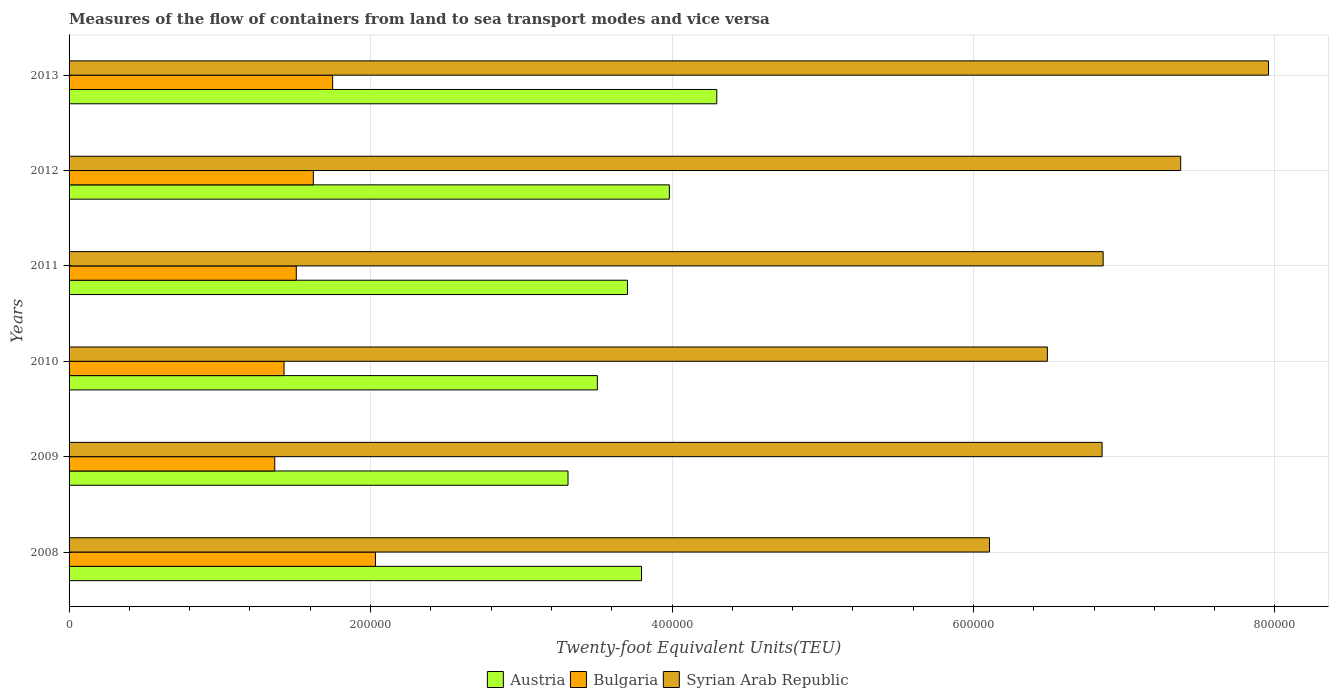Are the number of bars per tick equal to the number of legend labels?
Your response must be concise. Yes. How many bars are there on the 2nd tick from the top?
Provide a succinct answer. 3. In how many cases, is the number of bars for a given year not equal to the number of legend labels?
Your response must be concise. 0. What is the container port traffic in Bulgaria in 2008?
Provide a succinct answer. 2.03e+05. Across all years, what is the maximum container port traffic in Austria?
Offer a very short reply. 4.30e+05. Across all years, what is the minimum container port traffic in Syrian Arab Republic?
Your answer should be compact. 6.11e+05. What is the total container port traffic in Syrian Arab Republic in the graph?
Your answer should be very brief. 4.16e+06. What is the difference between the container port traffic in Austria in 2009 and that in 2010?
Provide a short and direct response. -1.95e+04. What is the difference between the container port traffic in Austria in 2009 and the container port traffic in Syrian Arab Republic in 2013?
Keep it short and to the point. -4.65e+05. What is the average container port traffic in Syrian Arab Republic per year?
Provide a succinct answer. 6.94e+05. In the year 2008, what is the difference between the container port traffic in Bulgaria and container port traffic in Austria?
Keep it short and to the point. -1.76e+05. In how many years, is the container port traffic in Austria greater than 520000 TEU?
Provide a short and direct response. 0. What is the ratio of the container port traffic in Austria in 2010 to that in 2011?
Your answer should be compact. 0.95. Is the difference between the container port traffic in Bulgaria in 2009 and 2013 greater than the difference between the container port traffic in Austria in 2009 and 2013?
Make the answer very short. Yes. What is the difference between the highest and the second highest container port traffic in Bulgaria?
Your response must be concise. 2.84e+04. What is the difference between the highest and the lowest container port traffic in Austria?
Your response must be concise. 9.87e+04. Is the sum of the container port traffic in Bulgaria in 2011 and 2013 greater than the maximum container port traffic in Austria across all years?
Offer a very short reply. No. What does the 3rd bar from the top in 2010 represents?
Your answer should be compact. Austria. What does the 3rd bar from the bottom in 2012 represents?
Provide a short and direct response. Syrian Arab Republic. Is it the case that in every year, the sum of the container port traffic in Syrian Arab Republic and container port traffic in Bulgaria is greater than the container port traffic in Austria?
Your response must be concise. Yes. How many bars are there?
Provide a short and direct response. 18. Are all the bars in the graph horizontal?
Offer a terse response. Yes. How many years are there in the graph?
Give a very brief answer. 6. What is the difference between two consecutive major ticks on the X-axis?
Ensure brevity in your answer.  2.00e+05. Does the graph contain any zero values?
Your answer should be compact. No. Does the graph contain grids?
Offer a very short reply. Yes. Where does the legend appear in the graph?
Provide a short and direct response. Bottom center. What is the title of the graph?
Offer a terse response. Measures of the flow of containers from land to sea transport modes and vice versa. Does "Sweden" appear as one of the legend labels in the graph?
Offer a terse response. No. What is the label or title of the X-axis?
Make the answer very short. Twenty-foot Equivalent Units(TEU). What is the Twenty-foot Equivalent Units(TEU) in Austria in 2008?
Make the answer very short. 3.80e+05. What is the Twenty-foot Equivalent Units(TEU) of Bulgaria in 2008?
Provide a succinct answer. 2.03e+05. What is the Twenty-foot Equivalent Units(TEU) of Syrian Arab Republic in 2008?
Offer a very short reply. 6.11e+05. What is the Twenty-foot Equivalent Units(TEU) in Austria in 2009?
Ensure brevity in your answer.  3.31e+05. What is the Twenty-foot Equivalent Units(TEU) in Bulgaria in 2009?
Make the answer very short. 1.36e+05. What is the Twenty-foot Equivalent Units(TEU) of Syrian Arab Republic in 2009?
Keep it short and to the point. 6.85e+05. What is the Twenty-foot Equivalent Units(TEU) of Austria in 2010?
Keep it short and to the point. 3.50e+05. What is the Twenty-foot Equivalent Units(TEU) of Bulgaria in 2010?
Ensure brevity in your answer.  1.43e+05. What is the Twenty-foot Equivalent Units(TEU) of Syrian Arab Republic in 2010?
Provide a succinct answer. 6.49e+05. What is the Twenty-foot Equivalent Units(TEU) in Austria in 2011?
Ensure brevity in your answer.  3.70e+05. What is the Twenty-foot Equivalent Units(TEU) of Bulgaria in 2011?
Keep it short and to the point. 1.51e+05. What is the Twenty-foot Equivalent Units(TEU) of Syrian Arab Republic in 2011?
Give a very brief answer. 6.86e+05. What is the Twenty-foot Equivalent Units(TEU) in Austria in 2012?
Provide a short and direct response. 3.98e+05. What is the Twenty-foot Equivalent Units(TEU) of Bulgaria in 2012?
Offer a very short reply. 1.62e+05. What is the Twenty-foot Equivalent Units(TEU) in Syrian Arab Republic in 2012?
Make the answer very short. 7.37e+05. What is the Twenty-foot Equivalent Units(TEU) of Austria in 2013?
Offer a very short reply. 4.30e+05. What is the Twenty-foot Equivalent Units(TEU) of Bulgaria in 2013?
Offer a terse response. 1.75e+05. What is the Twenty-foot Equivalent Units(TEU) in Syrian Arab Republic in 2013?
Provide a succinct answer. 7.96e+05. Across all years, what is the maximum Twenty-foot Equivalent Units(TEU) in Austria?
Provide a succinct answer. 4.30e+05. Across all years, what is the maximum Twenty-foot Equivalent Units(TEU) in Bulgaria?
Your response must be concise. 2.03e+05. Across all years, what is the maximum Twenty-foot Equivalent Units(TEU) in Syrian Arab Republic?
Provide a succinct answer. 7.96e+05. Across all years, what is the minimum Twenty-foot Equivalent Units(TEU) in Austria?
Offer a very short reply. 3.31e+05. Across all years, what is the minimum Twenty-foot Equivalent Units(TEU) of Bulgaria?
Your answer should be very brief. 1.36e+05. Across all years, what is the minimum Twenty-foot Equivalent Units(TEU) in Syrian Arab Republic?
Your response must be concise. 6.11e+05. What is the total Twenty-foot Equivalent Units(TEU) in Austria in the graph?
Offer a very short reply. 2.26e+06. What is the total Twenty-foot Equivalent Units(TEU) of Bulgaria in the graph?
Make the answer very short. 9.70e+05. What is the total Twenty-foot Equivalent Units(TEU) of Syrian Arab Republic in the graph?
Give a very brief answer. 4.16e+06. What is the difference between the Twenty-foot Equivalent Units(TEU) in Austria in 2008 and that in 2009?
Offer a very short reply. 4.87e+04. What is the difference between the Twenty-foot Equivalent Units(TEU) in Bulgaria in 2008 and that in 2009?
Offer a terse response. 6.68e+04. What is the difference between the Twenty-foot Equivalent Units(TEU) of Syrian Arab Republic in 2008 and that in 2009?
Offer a very short reply. -7.47e+04. What is the difference between the Twenty-foot Equivalent Units(TEU) in Austria in 2008 and that in 2010?
Provide a succinct answer. 2.93e+04. What is the difference between the Twenty-foot Equivalent Units(TEU) in Bulgaria in 2008 and that in 2010?
Offer a very short reply. 6.06e+04. What is the difference between the Twenty-foot Equivalent Units(TEU) in Syrian Arab Republic in 2008 and that in 2010?
Make the answer very short. -3.84e+04. What is the difference between the Twenty-foot Equivalent Units(TEU) of Austria in 2008 and that in 2011?
Offer a terse response. 9303.43. What is the difference between the Twenty-foot Equivalent Units(TEU) of Bulgaria in 2008 and that in 2011?
Your answer should be very brief. 5.25e+04. What is the difference between the Twenty-foot Equivalent Units(TEU) of Syrian Arab Republic in 2008 and that in 2011?
Offer a very short reply. -7.54e+04. What is the difference between the Twenty-foot Equivalent Units(TEU) of Austria in 2008 and that in 2012?
Your answer should be compact. -1.85e+04. What is the difference between the Twenty-foot Equivalent Units(TEU) of Bulgaria in 2008 and that in 2012?
Offer a very short reply. 4.12e+04. What is the difference between the Twenty-foot Equivalent Units(TEU) of Syrian Arab Republic in 2008 and that in 2012?
Give a very brief answer. -1.27e+05. What is the difference between the Twenty-foot Equivalent Units(TEU) of Austria in 2008 and that in 2013?
Offer a very short reply. -4.99e+04. What is the difference between the Twenty-foot Equivalent Units(TEU) in Bulgaria in 2008 and that in 2013?
Offer a terse response. 2.84e+04. What is the difference between the Twenty-foot Equivalent Units(TEU) of Syrian Arab Republic in 2008 and that in 2013?
Your answer should be compact. -1.85e+05. What is the difference between the Twenty-foot Equivalent Units(TEU) in Austria in 2009 and that in 2010?
Keep it short and to the point. -1.95e+04. What is the difference between the Twenty-foot Equivalent Units(TEU) in Bulgaria in 2009 and that in 2010?
Your answer should be very brief. -6167. What is the difference between the Twenty-foot Equivalent Units(TEU) in Syrian Arab Republic in 2009 and that in 2010?
Offer a very short reply. 3.63e+04. What is the difference between the Twenty-foot Equivalent Units(TEU) in Austria in 2009 and that in 2011?
Offer a terse response. -3.94e+04. What is the difference between the Twenty-foot Equivalent Units(TEU) in Bulgaria in 2009 and that in 2011?
Keep it short and to the point. -1.43e+04. What is the difference between the Twenty-foot Equivalent Units(TEU) in Syrian Arab Republic in 2009 and that in 2011?
Ensure brevity in your answer.  -699.28. What is the difference between the Twenty-foot Equivalent Units(TEU) in Austria in 2009 and that in 2012?
Keep it short and to the point. -6.72e+04. What is the difference between the Twenty-foot Equivalent Units(TEU) of Bulgaria in 2009 and that in 2012?
Offer a very short reply. -2.56e+04. What is the difference between the Twenty-foot Equivalent Units(TEU) in Syrian Arab Republic in 2009 and that in 2012?
Your answer should be compact. -5.21e+04. What is the difference between the Twenty-foot Equivalent Units(TEU) of Austria in 2009 and that in 2013?
Your answer should be compact. -9.87e+04. What is the difference between the Twenty-foot Equivalent Units(TEU) in Bulgaria in 2009 and that in 2013?
Your response must be concise. -3.84e+04. What is the difference between the Twenty-foot Equivalent Units(TEU) of Syrian Arab Republic in 2009 and that in 2013?
Keep it short and to the point. -1.10e+05. What is the difference between the Twenty-foot Equivalent Units(TEU) in Austria in 2010 and that in 2011?
Offer a terse response. -2.00e+04. What is the difference between the Twenty-foot Equivalent Units(TEU) in Bulgaria in 2010 and that in 2011?
Your response must be concise. -8128.83. What is the difference between the Twenty-foot Equivalent Units(TEU) in Syrian Arab Republic in 2010 and that in 2011?
Your answer should be compact. -3.70e+04. What is the difference between the Twenty-foot Equivalent Units(TEU) in Austria in 2010 and that in 2012?
Give a very brief answer. -4.78e+04. What is the difference between the Twenty-foot Equivalent Units(TEU) of Bulgaria in 2010 and that in 2012?
Offer a very short reply. -1.94e+04. What is the difference between the Twenty-foot Equivalent Units(TEU) in Syrian Arab Republic in 2010 and that in 2012?
Your answer should be very brief. -8.84e+04. What is the difference between the Twenty-foot Equivalent Units(TEU) in Austria in 2010 and that in 2013?
Your answer should be very brief. -7.92e+04. What is the difference between the Twenty-foot Equivalent Units(TEU) of Bulgaria in 2010 and that in 2013?
Your answer should be compact. -3.22e+04. What is the difference between the Twenty-foot Equivalent Units(TEU) in Syrian Arab Republic in 2010 and that in 2013?
Provide a short and direct response. -1.47e+05. What is the difference between the Twenty-foot Equivalent Units(TEU) of Austria in 2011 and that in 2012?
Provide a succinct answer. -2.78e+04. What is the difference between the Twenty-foot Equivalent Units(TEU) of Bulgaria in 2011 and that in 2012?
Ensure brevity in your answer.  -1.13e+04. What is the difference between the Twenty-foot Equivalent Units(TEU) of Syrian Arab Republic in 2011 and that in 2012?
Ensure brevity in your answer.  -5.14e+04. What is the difference between the Twenty-foot Equivalent Units(TEU) in Austria in 2011 and that in 2013?
Your answer should be very brief. -5.92e+04. What is the difference between the Twenty-foot Equivalent Units(TEU) of Bulgaria in 2011 and that in 2013?
Ensure brevity in your answer.  -2.41e+04. What is the difference between the Twenty-foot Equivalent Units(TEU) in Syrian Arab Republic in 2011 and that in 2013?
Keep it short and to the point. -1.10e+05. What is the difference between the Twenty-foot Equivalent Units(TEU) in Austria in 2012 and that in 2013?
Offer a terse response. -3.15e+04. What is the difference between the Twenty-foot Equivalent Units(TEU) of Bulgaria in 2012 and that in 2013?
Provide a short and direct response. -1.28e+04. What is the difference between the Twenty-foot Equivalent Units(TEU) in Syrian Arab Republic in 2012 and that in 2013?
Your answer should be compact. -5.83e+04. What is the difference between the Twenty-foot Equivalent Units(TEU) in Austria in 2008 and the Twenty-foot Equivalent Units(TEU) in Bulgaria in 2009?
Offer a terse response. 2.43e+05. What is the difference between the Twenty-foot Equivalent Units(TEU) in Austria in 2008 and the Twenty-foot Equivalent Units(TEU) in Syrian Arab Republic in 2009?
Provide a succinct answer. -3.06e+05. What is the difference between the Twenty-foot Equivalent Units(TEU) in Bulgaria in 2008 and the Twenty-foot Equivalent Units(TEU) in Syrian Arab Republic in 2009?
Provide a short and direct response. -4.82e+05. What is the difference between the Twenty-foot Equivalent Units(TEU) in Austria in 2008 and the Twenty-foot Equivalent Units(TEU) in Bulgaria in 2010?
Offer a very short reply. 2.37e+05. What is the difference between the Twenty-foot Equivalent Units(TEU) of Austria in 2008 and the Twenty-foot Equivalent Units(TEU) of Syrian Arab Republic in 2010?
Offer a terse response. -2.69e+05. What is the difference between the Twenty-foot Equivalent Units(TEU) in Bulgaria in 2008 and the Twenty-foot Equivalent Units(TEU) in Syrian Arab Republic in 2010?
Provide a short and direct response. -4.46e+05. What is the difference between the Twenty-foot Equivalent Units(TEU) in Austria in 2008 and the Twenty-foot Equivalent Units(TEU) in Bulgaria in 2011?
Your response must be concise. 2.29e+05. What is the difference between the Twenty-foot Equivalent Units(TEU) in Austria in 2008 and the Twenty-foot Equivalent Units(TEU) in Syrian Arab Republic in 2011?
Provide a succinct answer. -3.06e+05. What is the difference between the Twenty-foot Equivalent Units(TEU) of Bulgaria in 2008 and the Twenty-foot Equivalent Units(TEU) of Syrian Arab Republic in 2011?
Ensure brevity in your answer.  -4.83e+05. What is the difference between the Twenty-foot Equivalent Units(TEU) in Austria in 2008 and the Twenty-foot Equivalent Units(TEU) in Bulgaria in 2012?
Keep it short and to the point. 2.18e+05. What is the difference between the Twenty-foot Equivalent Units(TEU) of Austria in 2008 and the Twenty-foot Equivalent Units(TEU) of Syrian Arab Republic in 2012?
Provide a short and direct response. -3.58e+05. What is the difference between the Twenty-foot Equivalent Units(TEU) of Bulgaria in 2008 and the Twenty-foot Equivalent Units(TEU) of Syrian Arab Republic in 2012?
Provide a short and direct response. -5.34e+05. What is the difference between the Twenty-foot Equivalent Units(TEU) of Austria in 2008 and the Twenty-foot Equivalent Units(TEU) of Bulgaria in 2013?
Your response must be concise. 2.05e+05. What is the difference between the Twenty-foot Equivalent Units(TEU) of Austria in 2008 and the Twenty-foot Equivalent Units(TEU) of Syrian Arab Republic in 2013?
Offer a terse response. -4.16e+05. What is the difference between the Twenty-foot Equivalent Units(TEU) of Bulgaria in 2008 and the Twenty-foot Equivalent Units(TEU) of Syrian Arab Republic in 2013?
Your response must be concise. -5.92e+05. What is the difference between the Twenty-foot Equivalent Units(TEU) of Austria in 2009 and the Twenty-foot Equivalent Units(TEU) of Bulgaria in 2010?
Offer a very short reply. 1.88e+05. What is the difference between the Twenty-foot Equivalent Units(TEU) in Austria in 2009 and the Twenty-foot Equivalent Units(TEU) in Syrian Arab Republic in 2010?
Your answer should be compact. -3.18e+05. What is the difference between the Twenty-foot Equivalent Units(TEU) in Bulgaria in 2009 and the Twenty-foot Equivalent Units(TEU) in Syrian Arab Republic in 2010?
Offer a terse response. -5.13e+05. What is the difference between the Twenty-foot Equivalent Units(TEU) in Austria in 2009 and the Twenty-foot Equivalent Units(TEU) in Bulgaria in 2011?
Your answer should be very brief. 1.80e+05. What is the difference between the Twenty-foot Equivalent Units(TEU) in Austria in 2009 and the Twenty-foot Equivalent Units(TEU) in Syrian Arab Republic in 2011?
Provide a succinct answer. -3.55e+05. What is the difference between the Twenty-foot Equivalent Units(TEU) in Bulgaria in 2009 and the Twenty-foot Equivalent Units(TEU) in Syrian Arab Republic in 2011?
Your answer should be compact. -5.50e+05. What is the difference between the Twenty-foot Equivalent Units(TEU) in Austria in 2009 and the Twenty-foot Equivalent Units(TEU) in Bulgaria in 2012?
Your answer should be very brief. 1.69e+05. What is the difference between the Twenty-foot Equivalent Units(TEU) in Austria in 2009 and the Twenty-foot Equivalent Units(TEU) in Syrian Arab Republic in 2012?
Provide a short and direct response. -4.06e+05. What is the difference between the Twenty-foot Equivalent Units(TEU) of Bulgaria in 2009 and the Twenty-foot Equivalent Units(TEU) of Syrian Arab Republic in 2012?
Offer a terse response. -6.01e+05. What is the difference between the Twenty-foot Equivalent Units(TEU) of Austria in 2009 and the Twenty-foot Equivalent Units(TEU) of Bulgaria in 2013?
Your answer should be very brief. 1.56e+05. What is the difference between the Twenty-foot Equivalent Units(TEU) of Austria in 2009 and the Twenty-foot Equivalent Units(TEU) of Syrian Arab Republic in 2013?
Your answer should be compact. -4.65e+05. What is the difference between the Twenty-foot Equivalent Units(TEU) of Bulgaria in 2009 and the Twenty-foot Equivalent Units(TEU) of Syrian Arab Republic in 2013?
Provide a succinct answer. -6.59e+05. What is the difference between the Twenty-foot Equivalent Units(TEU) of Austria in 2010 and the Twenty-foot Equivalent Units(TEU) of Bulgaria in 2011?
Make the answer very short. 2.00e+05. What is the difference between the Twenty-foot Equivalent Units(TEU) in Austria in 2010 and the Twenty-foot Equivalent Units(TEU) in Syrian Arab Republic in 2011?
Your response must be concise. -3.36e+05. What is the difference between the Twenty-foot Equivalent Units(TEU) in Bulgaria in 2010 and the Twenty-foot Equivalent Units(TEU) in Syrian Arab Republic in 2011?
Offer a terse response. -5.43e+05. What is the difference between the Twenty-foot Equivalent Units(TEU) of Austria in 2010 and the Twenty-foot Equivalent Units(TEU) of Bulgaria in 2012?
Give a very brief answer. 1.88e+05. What is the difference between the Twenty-foot Equivalent Units(TEU) in Austria in 2010 and the Twenty-foot Equivalent Units(TEU) in Syrian Arab Republic in 2012?
Give a very brief answer. -3.87e+05. What is the difference between the Twenty-foot Equivalent Units(TEU) of Bulgaria in 2010 and the Twenty-foot Equivalent Units(TEU) of Syrian Arab Republic in 2012?
Offer a terse response. -5.95e+05. What is the difference between the Twenty-foot Equivalent Units(TEU) in Austria in 2010 and the Twenty-foot Equivalent Units(TEU) in Bulgaria in 2013?
Keep it short and to the point. 1.76e+05. What is the difference between the Twenty-foot Equivalent Units(TEU) in Austria in 2010 and the Twenty-foot Equivalent Units(TEU) in Syrian Arab Republic in 2013?
Make the answer very short. -4.45e+05. What is the difference between the Twenty-foot Equivalent Units(TEU) in Bulgaria in 2010 and the Twenty-foot Equivalent Units(TEU) in Syrian Arab Republic in 2013?
Your answer should be compact. -6.53e+05. What is the difference between the Twenty-foot Equivalent Units(TEU) in Austria in 2011 and the Twenty-foot Equivalent Units(TEU) in Bulgaria in 2012?
Give a very brief answer. 2.08e+05. What is the difference between the Twenty-foot Equivalent Units(TEU) of Austria in 2011 and the Twenty-foot Equivalent Units(TEU) of Syrian Arab Republic in 2012?
Keep it short and to the point. -3.67e+05. What is the difference between the Twenty-foot Equivalent Units(TEU) of Bulgaria in 2011 and the Twenty-foot Equivalent Units(TEU) of Syrian Arab Republic in 2012?
Make the answer very short. -5.87e+05. What is the difference between the Twenty-foot Equivalent Units(TEU) in Austria in 2011 and the Twenty-foot Equivalent Units(TEU) in Bulgaria in 2013?
Offer a terse response. 1.96e+05. What is the difference between the Twenty-foot Equivalent Units(TEU) of Austria in 2011 and the Twenty-foot Equivalent Units(TEU) of Syrian Arab Republic in 2013?
Provide a succinct answer. -4.25e+05. What is the difference between the Twenty-foot Equivalent Units(TEU) of Bulgaria in 2011 and the Twenty-foot Equivalent Units(TEU) of Syrian Arab Republic in 2013?
Provide a succinct answer. -6.45e+05. What is the difference between the Twenty-foot Equivalent Units(TEU) of Austria in 2012 and the Twenty-foot Equivalent Units(TEU) of Bulgaria in 2013?
Ensure brevity in your answer.  2.23e+05. What is the difference between the Twenty-foot Equivalent Units(TEU) in Austria in 2012 and the Twenty-foot Equivalent Units(TEU) in Syrian Arab Republic in 2013?
Give a very brief answer. -3.97e+05. What is the difference between the Twenty-foot Equivalent Units(TEU) in Bulgaria in 2012 and the Twenty-foot Equivalent Units(TEU) in Syrian Arab Republic in 2013?
Your response must be concise. -6.34e+05. What is the average Twenty-foot Equivalent Units(TEU) in Austria per year?
Make the answer very short. 3.77e+05. What is the average Twenty-foot Equivalent Units(TEU) of Bulgaria per year?
Your response must be concise. 1.62e+05. What is the average Twenty-foot Equivalent Units(TEU) of Syrian Arab Republic per year?
Provide a succinct answer. 6.94e+05. In the year 2008, what is the difference between the Twenty-foot Equivalent Units(TEU) of Austria and Twenty-foot Equivalent Units(TEU) of Bulgaria?
Provide a short and direct response. 1.76e+05. In the year 2008, what is the difference between the Twenty-foot Equivalent Units(TEU) of Austria and Twenty-foot Equivalent Units(TEU) of Syrian Arab Republic?
Give a very brief answer. -2.31e+05. In the year 2008, what is the difference between the Twenty-foot Equivalent Units(TEU) in Bulgaria and Twenty-foot Equivalent Units(TEU) in Syrian Arab Republic?
Offer a very short reply. -4.07e+05. In the year 2009, what is the difference between the Twenty-foot Equivalent Units(TEU) of Austria and Twenty-foot Equivalent Units(TEU) of Bulgaria?
Provide a short and direct response. 1.95e+05. In the year 2009, what is the difference between the Twenty-foot Equivalent Units(TEU) of Austria and Twenty-foot Equivalent Units(TEU) of Syrian Arab Republic?
Offer a terse response. -3.54e+05. In the year 2009, what is the difference between the Twenty-foot Equivalent Units(TEU) of Bulgaria and Twenty-foot Equivalent Units(TEU) of Syrian Arab Republic?
Ensure brevity in your answer.  -5.49e+05. In the year 2010, what is the difference between the Twenty-foot Equivalent Units(TEU) in Austria and Twenty-foot Equivalent Units(TEU) in Bulgaria?
Offer a very short reply. 2.08e+05. In the year 2010, what is the difference between the Twenty-foot Equivalent Units(TEU) in Austria and Twenty-foot Equivalent Units(TEU) in Syrian Arab Republic?
Your response must be concise. -2.99e+05. In the year 2010, what is the difference between the Twenty-foot Equivalent Units(TEU) in Bulgaria and Twenty-foot Equivalent Units(TEU) in Syrian Arab Republic?
Your response must be concise. -5.06e+05. In the year 2011, what is the difference between the Twenty-foot Equivalent Units(TEU) of Austria and Twenty-foot Equivalent Units(TEU) of Bulgaria?
Provide a short and direct response. 2.20e+05. In the year 2011, what is the difference between the Twenty-foot Equivalent Units(TEU) in Austria and Twenty-foot Equivalent Units(TEU) in Syrian Arab Republic?
Keep it short and to the point. -3.16e+05. In the year 2011, what is the difference between the Twenty-foot Equivalent Units(TEU) of Bulgaria and Twenty-foot Equivalent Units(TEU) of Syrian Arab Republic?
Your response must be concise. -5.35e+05. In the year 2012, what is the difference between the Twenty-foot Equivalent Units(TEU) in Austria and Twenty-foot Equivalent Units(TEU) in Bulgaria?
Give a very brief answer. 2.36e+05. In the year 2012, what is the difference between the Twenty-foot Equivalent Units(TEU) of Austria and Twenty-foot Equivalent Units(TEU) of Syrian Arab Republic?
Offer a terse response. -3.39e+05. In the year 2012, what is the difference between the Twenty-foot Equivalent Units(TEU) in Bulgaria and Twenty-foot Equivalent Units(TEU) in Syrian Arab Republic?
Give a very brief answer. -5.75e+05. In the year 2013, what is the difference between the Twenty-foot Equivalent Units(TEU) in Austria and Twenty-foot Equivalent Units(TEU) in Bulgaria?
Your answer should be compact. 2.55e+05. In the year 2013, what is the difference between the Twenty-foot Equivalent Units(TEU) of Austria and Twenty-foot Equivalent Units(TEU) of Syrian Arab Republic?
Ensure brevity in your answer.  -3.66e+05. In the year 2013, what is the difference between the Twenty-foot Equivalent Units(TEU) in Bulgaria and Twenty-foot Equivalent Units(TEU) in Syrian Arab Republic?
Give a very brief answer. -6.21e+05. What is the ratio of the Twenty-foot Equivalent Units(TEU) of Austria in 2008 to that in 2009?
Offer a terse response. 1.15. What is the ratio of the Twenty-foot Equivalent Units(TEU) in Bulgaria in 2008 to that in 2009?
Provide a succinct answer. 1.49. What is the ratio of the Twenty-foot Equivalent Units(TEU) in Syrian Arab Republic in 2008 to that in 2009?
Provide a short and direct response. 0.89. What is the ratio of the Twenty-foot Equivalent Units(TEU) of Austria in 2008 to that in 2010?
Provide a short and direct response. 1.08. What is the ratio of the Twenty-foot Equivalent Units(TEU) of Bulgaria in 2008 to that in 2010?
Provide a short and direct response. 1.43. What is the ratio of the Twenty-foot Equivalent Units(TEU) in Syrian Arab Republic in 2008 to that in 2010?
Keep it short and to the point. 0.94. What is the ratio of the Twenty-foot Equivalent Units(TEU) in Austria in 2008 to that in 2011?
Offer a terse response. 1.03. What is the ratio of the Twenty-foot Equivalent Units(TEU) of Bulgaria in 2008 to that in 2011?
Keep it short and to the point. 1.35. What is the ratio of the Twenty-foot Equivalent Units(TEU) of Syrian Arab Republic in 2008 to that in 2011?
Keep it short and to the point. 0.89. What is the ratio of the Twenty-foot Equivalent Units(TEU) in Austria in 2008 to that in 2012?
Offer a very short reply. 0.95. What is the ratio of the Twenty-foot Equivalent Units(TEU) in Bulgaria in 2008 to that in 2012?
Give a very brief answer. 1.25. What is the ratio of the Twenty-foot Equivalent Units(TEU) in Syrian Arab Republic in 2008 to that in 2012?
Ensure brevity in your answer.  0.83. What is the ratio of the Twenty-foot Equivalent Units(TEU) in Austria in 2008 to that in 2013?
Ensure brevity in your answer.  0.88. What is the ratio of the Twenty-foot Equivalent Units(TEU) of Bulgaria in 2008 to that in 2013?
Your answer should be compact. 1.16. What is the ratio of the Twenty-foot Equivalent Units(TEU) in Syrian Arab Republic in 2008 to that in 2013?
Ensure brevity in your answer.  0.77. What is the ratio of the Twenty-foot Equivalent Units(TEU) in Austria in 2009 to that in 2010?
Your response must be concise. 0.94. What is the ratio of the Twenty-foot Equivalent Units(TEU) in Bulgaria in 2009 to that in 2010?
Provide a succinct answer. 0.96. What is the ratio of the Twenty-foot Equivalent Units(TEU) in Syrian Arab Republic in 2009 to that in 2010?
Make the answer very short. 1.06. What is the ratio of the Twenty-foot Equivalent Units(TEU) in Austria in 2009 to that in 2011?
Your response must be concise. 0.89. What is the ratio of the Twenty-foot Equivalent Units(TEU) of Bulgaria in 2009 to that in 2011?
Your answer should be very brief. 0.91. What is the ratio of the Twenty-foot Equivalent Units(TEU) in Austria in 2009 to that in 2012?
Give a very brief answer. 0.83. What is the ratio of the Twenty-foot Equivalent Units(TEU) in Bulgaria in 2009 to that in 2012?
Offer a terse response. 0.84. What is the ratio of the Twenty-foot Equivalent Units(TEU) of Syrian Arab Republic in 2009 to that in 2012?
Your answer should be compact. 0.93. What is the ratio of the Twenty-foot Equivalent Units(TEU) in Austria in 2009 to that in 2013?
Offer a very short reply. 0.77. What is the ratio of the Twenty-foot Equivalent Units(TEU) in Bulgaria in 2009 to that in 2013?
Ensure brevity in your answer.  0.78. What is the ratio of the Twenty-foot Equivalent Units(TEU) of Syrian Arab Republic in 2009 to that in 2013?
Your answer should be compact. 0.86. What is the ratio of the Twenty-foot Equivalent Units(TEU) in Austria in 2010 to that in 2011?
Offer a very short reply. 0.95. What is the ratio of the Twenty-foot Equivalent Units(TEU) of Bulgaria in 2010 to that in 2011?
Your response must be concise. 0.95. What is the ratio of the Twenty-foot Equivalent Units(TEU) of Syrian Arab Republic in 2010 to that in 2011?
Make the answer very short. 0.95. What is the ratio of the Twenty-foot Equivalent Units(TEU) in Austria in 2010 to that in 2012?
Ensure brevity in your answer.  0.88. What is the ratio of the Twenty-foot Equivalent Units(TEU) of Bulgaria in 2010 to that in 2012?
Keep it short and to the point. 0.88. What is the ratio of the Twenty-foot Equivalent Units(TEU) of Syrian Arab Republic in 2010 to that in 2012?
Your answer should be very brief. 0.88. What is the ratio of the Twenty-foot Equivalent Units(TEU) of Austria in 2010 to that in 2013?
Your response must be concise. 0.82. What is the ratio of the Twenty-foot Equivalent Units(TEU) in Bulgaria in 2010 to that in 2013?
Offer a terse response. 0.82. What is the ratio of the Twenty-foot Equivalent Units(TEU) of Syrian Arab Republic in 2010 to that in 2013?
Make the answer very short. 0.82. What is the ratio of the Twenty-foot Equivalent Units(TEU) in Austria in 2011 to that in 2012?
Give a very brief answer. 0.93. What is the ratio of the Twenty-foot Equivalent Units(TEU) in Bulgaria in 2011 to that in 2012?
Make the answer very short. 0.93. What is the ratio of the Twenty-foot Equivalent Units(TEU) in Syrian Arab Republic in 2011 to that in 2012?
Your response must be concise. 0.93. What is the ratio of the Twenty-foot Equivalent Units(TEU) in Austria in 2011 to that in 2013?
Your response must be concise. 0.86. What is the ratio of the Twenty-foot Equivalent Units(TEU) in Bulgaria in 2011 to that in 2013?
Offer a terse response. 0.86. What is the ratio of the Twenty-foot Equivalent Units(TEU) of Syrian Arab Republic in 2011 to that in 2013?
Offer a terse response. 0.86. What is the ratio of the Twenty-foot Equivalent Units(TEU) of Austria in 2012 to that in 2013?
Give a very brief answer. 0.93. What is the ratio of the Twenty-foot Equivalent Units(TEU) in Bulgaria in 2012 to that in 2013?
Provide a succinct answer. 0.93. What is the ratio of the Twenty-foot Equivalent Units(TEU) of Syrian Arab Republic in 2012 to that in 2013?
Your answer should be compact. 0.93. What is the difference between the highest and the second highest Twenty-foot Equivalent Units(TEU) of Austria?
Your answer should be very brief. 3.15e+04. What is the difference between the highest and the second highest Twenty-foot Equivalent Units(TEU) of Bulgaria?
Your answer should be very brief. 2.84e+04. What is the difference between the highest and the second highest Twenty-foot Equivalent Units(TEU) of Syrian Arab Republic?
Make the answer very short. 5.83e+04. What is the difference between the highest and the lowest Twenty-foot Equivalent Units(TEU) of Austria?
Make the answer very short. 9.87e+04. What is the difference between the highest and the lowest Twenty-foot Equivalent Units(TEU) of Bulgaria?
Offer a very short reply. 6.68e+04. What is the difference between the highest and the lowest Twenty-foot Equivalent Units(TEU) of Syrian Arab Republic?
Offer a very short reply. 1.85e+05. 